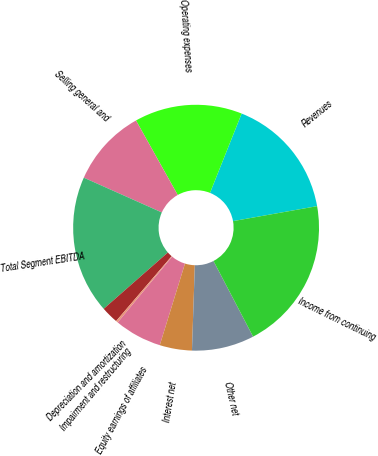Convert chart. <chart><loc_0><loc_0><loc_500><loc_500><pie_chart><fcel>Revenues<fcel>Operating expenses<fcel>Selling general and<fcel>Total Segment EBITDA<fcel>Depreciation and amortization<fcel>Impairment and restructuring<fcel>Equity earnings of affiliates<fcel>Interest net<fcel>Other net<fcel>Income from continuing<nl><fcel>16.15%<fcel>14.17%<fcel>10.2%<fcel>18.14%<fcel>2.26%<fcel>0.27%<fcel>6.23%<fcel>4.24%<fcel>8.21%<fcel>20.13%<nl></chart> 